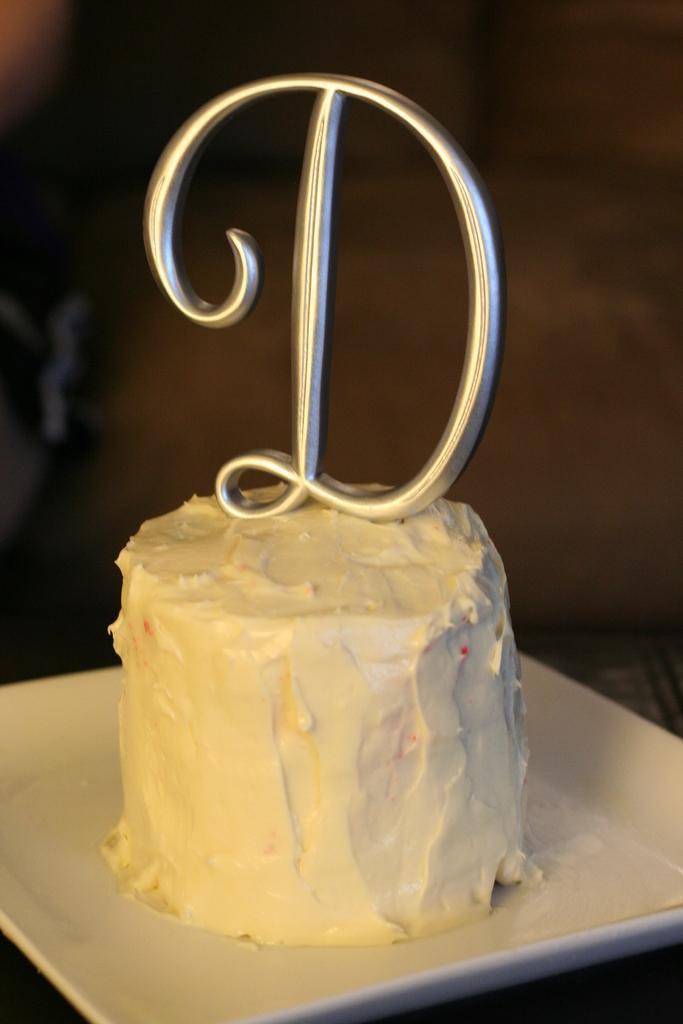In one or two sentences, can you explain what this image depicts? In this image we can see cake in a plate and we can see an alphabet on the cake. There is a blur background. 